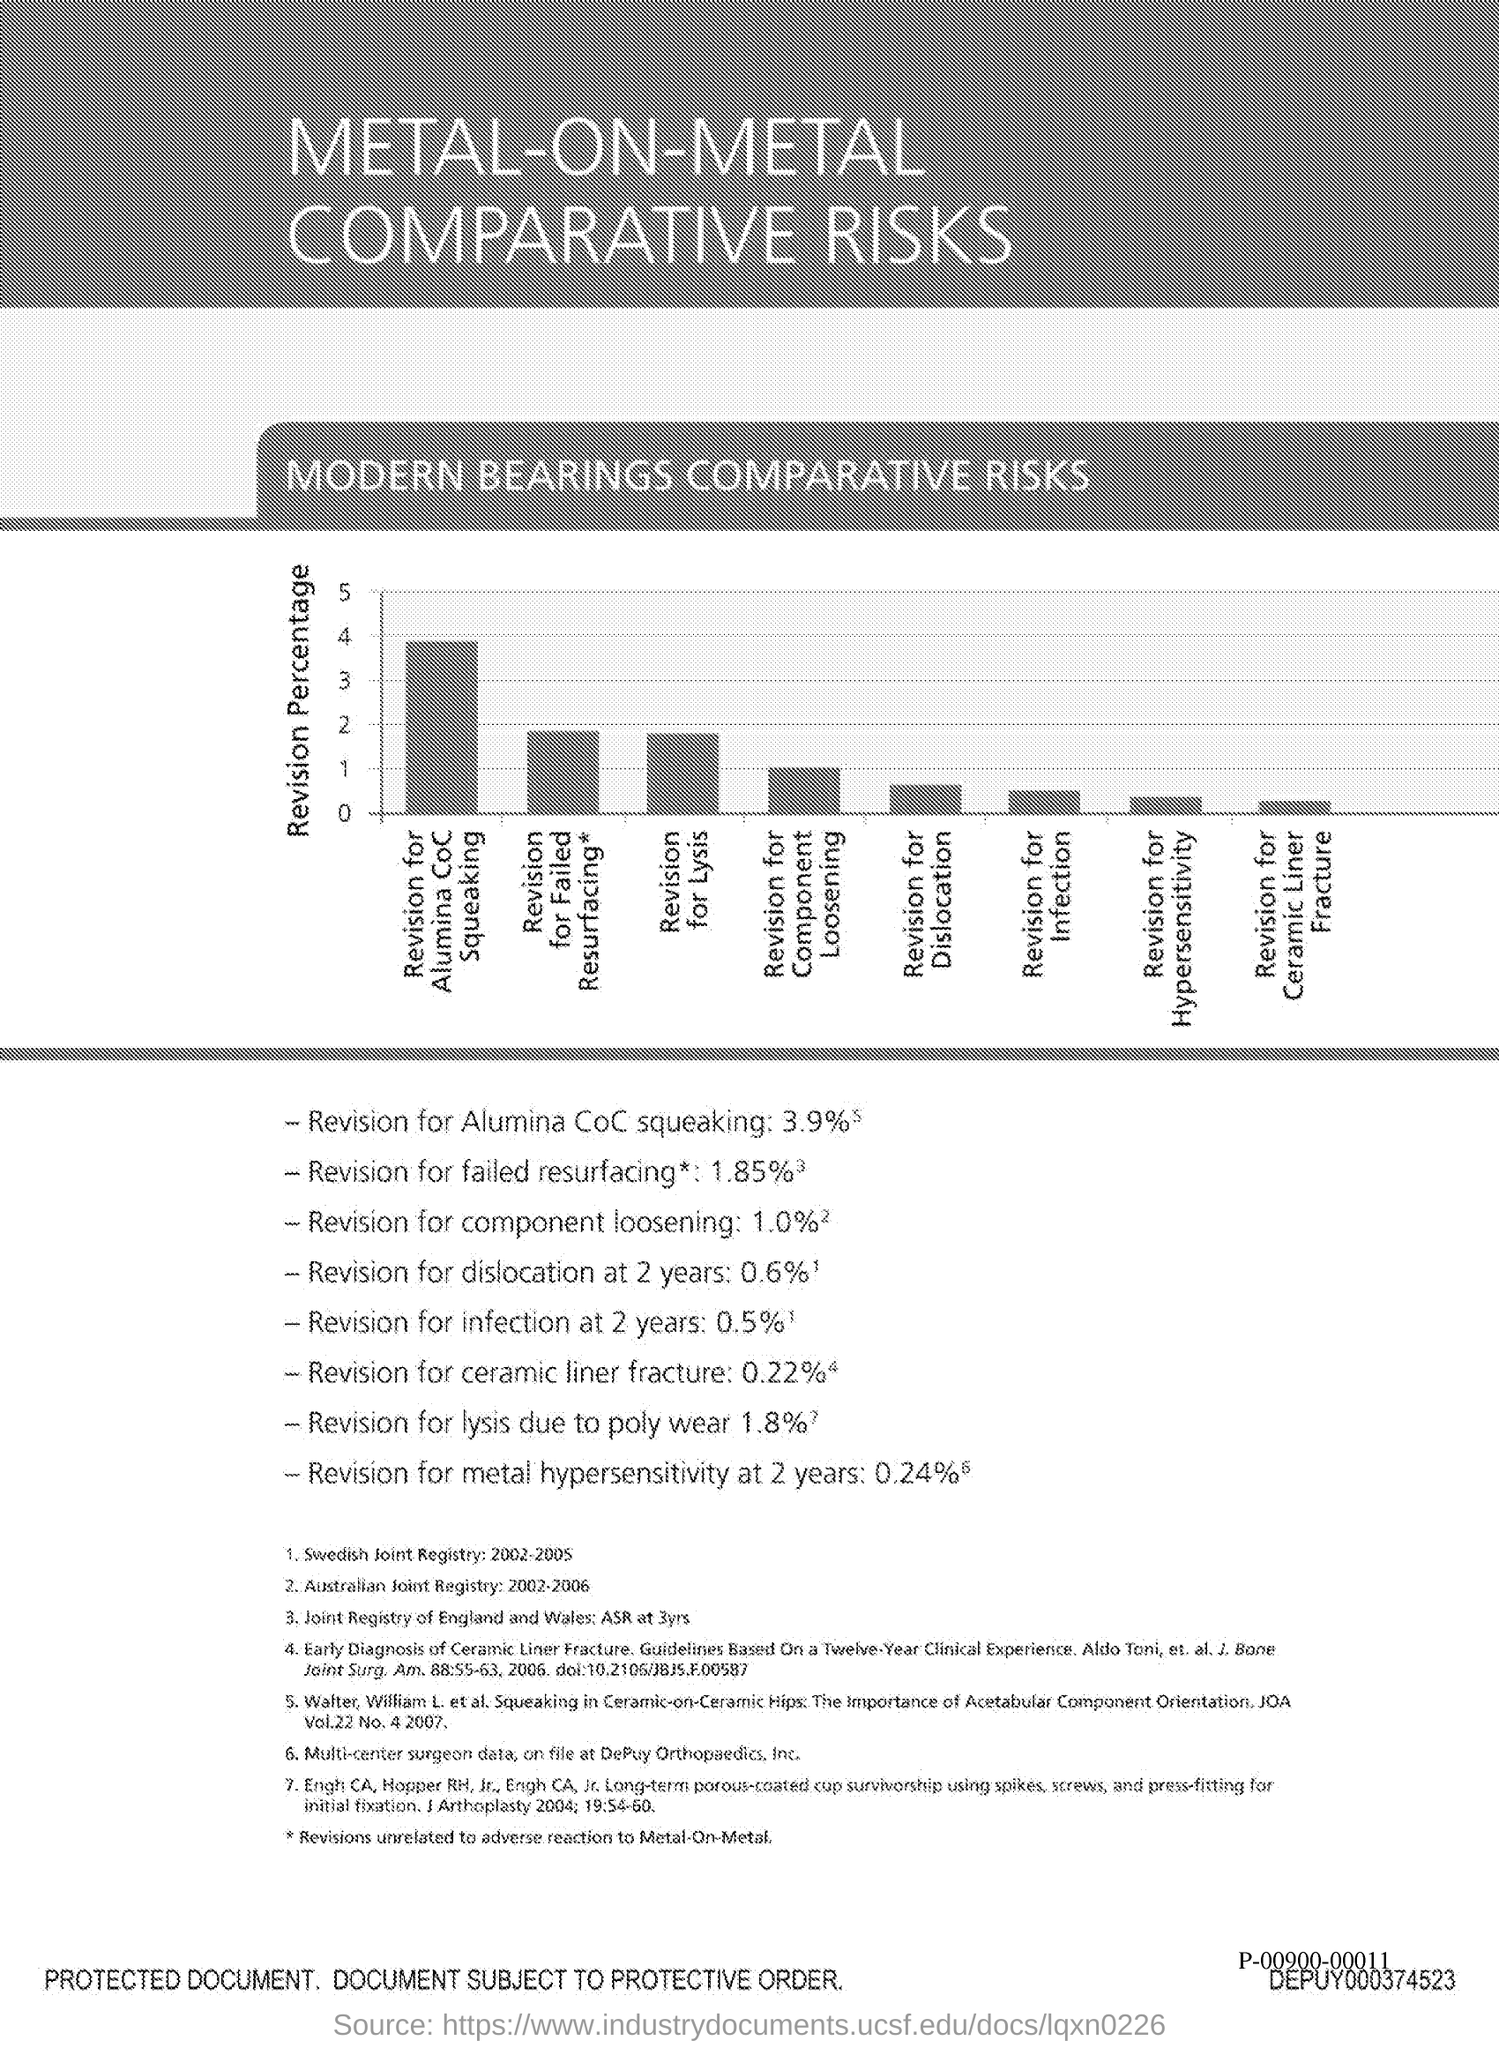Give some essential details in this illustration. The revision rate for Alumina ceramic coatings is 3.9%. The ceramic liner fracture revision rate is estimated to be 0.22%. A study found that at two years post-operatively, the rate of revision for dislocation was 0.6%. The revision rate for component loosening is between 1.0% and 10.0%. According to our data, the revision rate for failed resurfacing procedures is approximately 1.85%. 